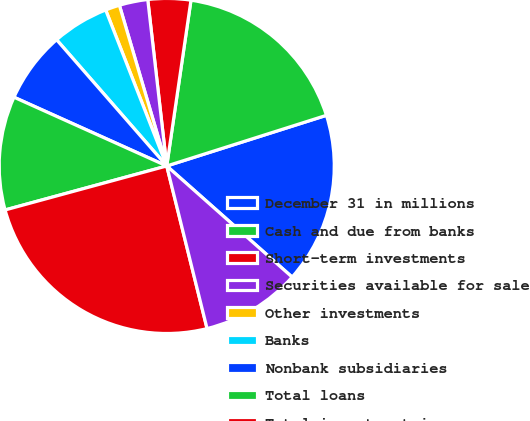<chart> <loc_0><loc_0><loc_500><loc_500><pie_chart><fcel>December 31 in millions<fcel>Cash and due from banks<fcel>Short-term investments<fcel>Securities available for sale<fcel>Other investments<fcel>Banks<fcel>Nonbank subsidiaries<fcel>Total loans<fcel>Total investment in<fcel>Goodwill<nl><fcel>16.43%<fcel>17.8%<fcel>4.12%<fcel>2.75%<fcel>1.38%<fcel>5.48%<fcel>6.85%<fcel>10.96%<fcel>24.64%<fcel>9.59%<nl></chart> 